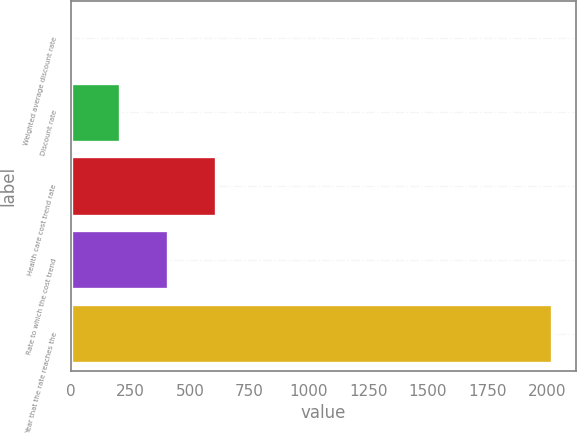Convert chart. <chart><loc_0><loc_0><loc_500><loc_500><bar_chart><fcel>Weighted average discount rate<fcel>Discount rate<fcel>Health care cost trend rate<fcel>Rate to which the cost trend<fcel>Year that the rate reaches the<nl><fcel>4.58<fcel>206.22<fcel>609.5<fcel>407.86<fcel>2021<nl></chart> 